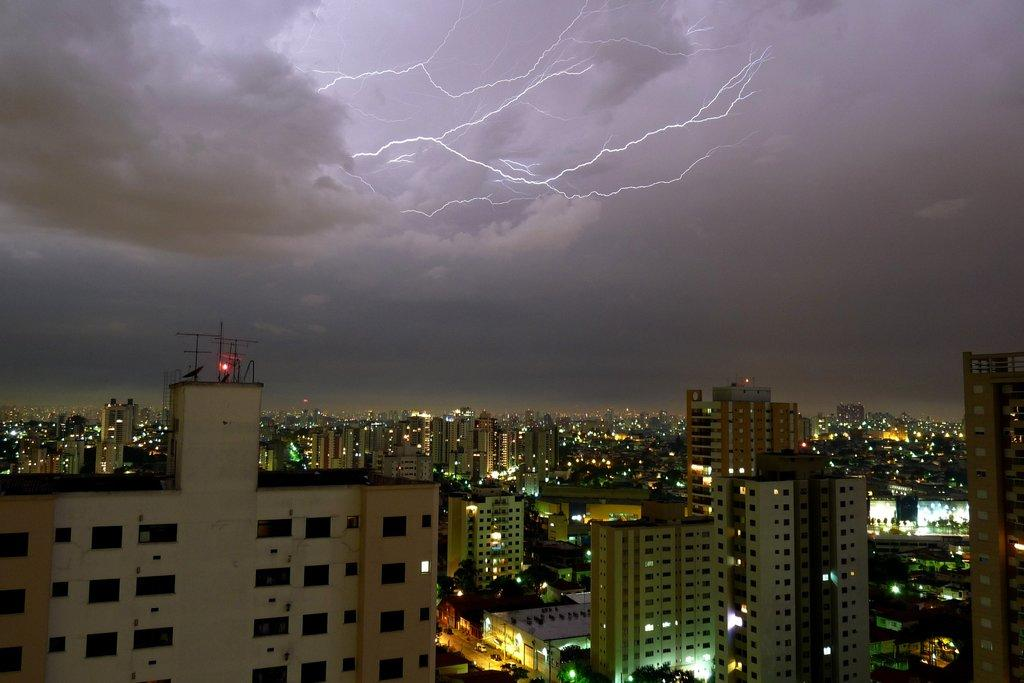What structures are located in the front of the image? There are buildings in the front of the image. What weather phenomenon can be seen in the sky? There are lightning strikes visible in the sky. What type of atmospheric conditions are present in the image? Clouds are present in the sky. Can you see a group of trees in the image? There is no group of trees present in the image. 